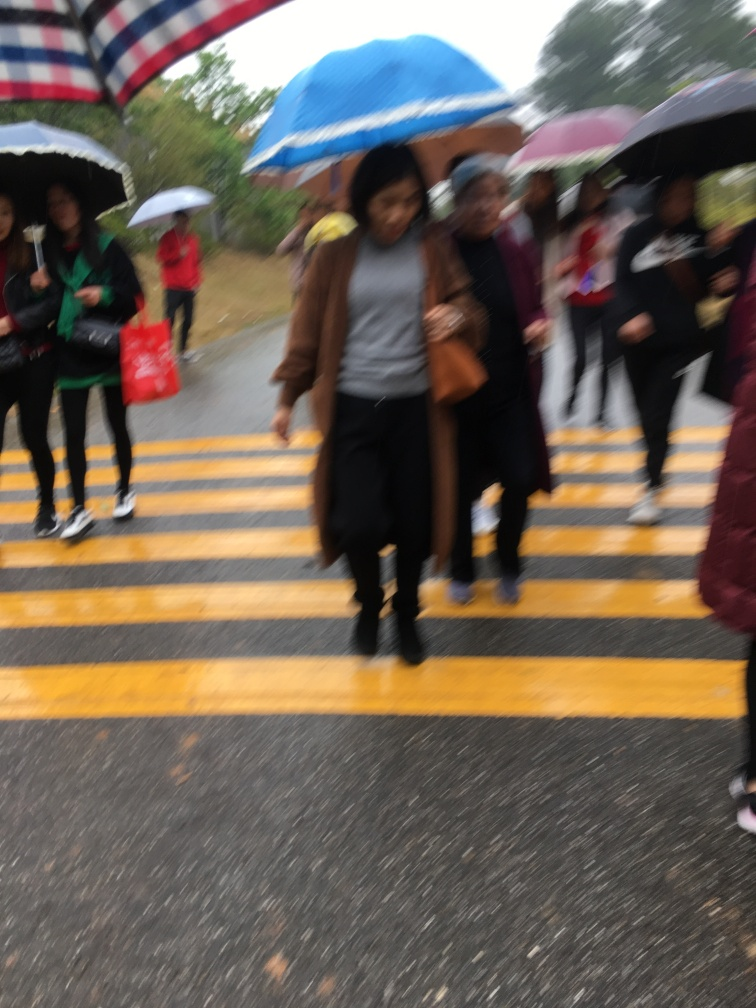Is the picture blurry? Yes, the picture is noticeably blurry, affecting the clarity of the subjects in the image, particularly the pedestrians crossing the street. This blurriness could be due to motion blur from the camera movement or a low shutter speed in a dynamic scene. 